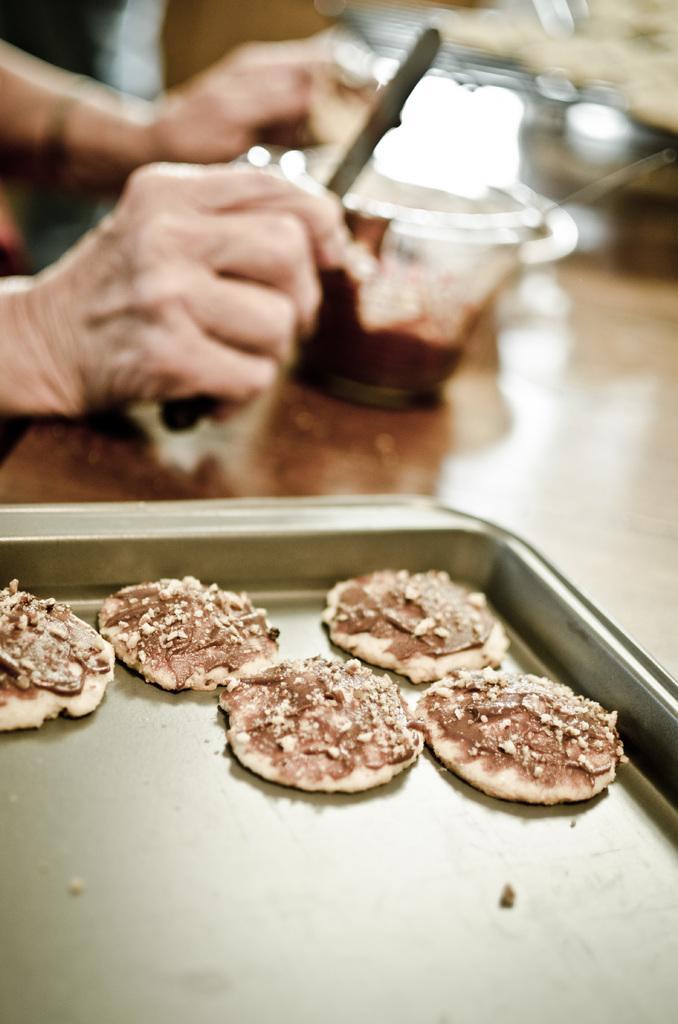Describe this image in one or two sentences. In this image we can see some cookies placed in a tray. We can also see the small glass with a syrup placed on the wooden table. On the left there is also some person holding the knife. 